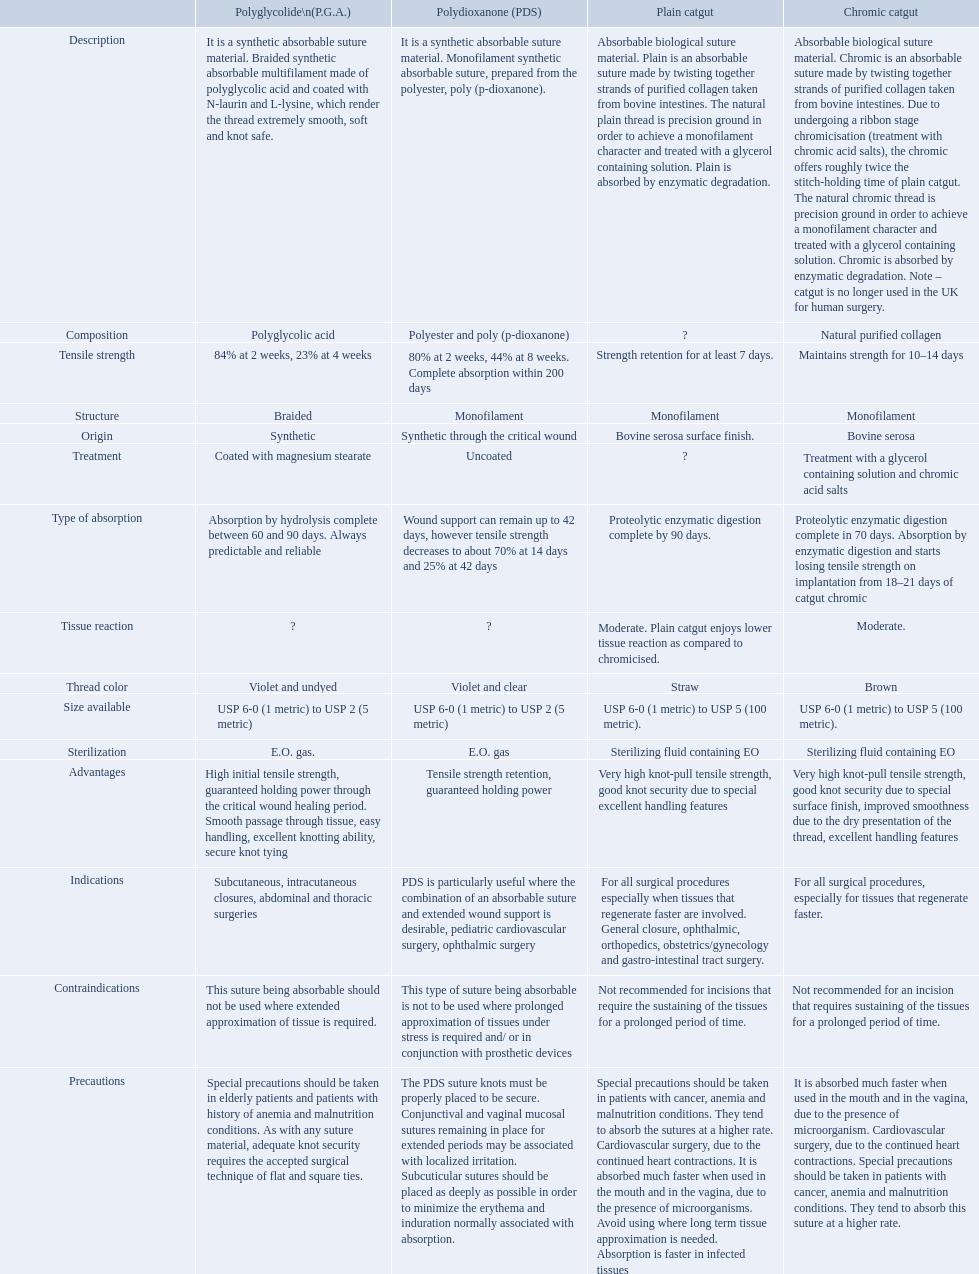Which are the different tensile strengths of the suture materials in the comparison chart? Strength retention for at least 7 days., Maintains strength for 10–14 days, 84% at 2 weeks, 23% at 4 weeks, 80% at 2 weeks, 44% at 8 weeks. Complete absorption within 200 days. Of these, which belongs to plain catgut? Strength retention for at least 7 days. 